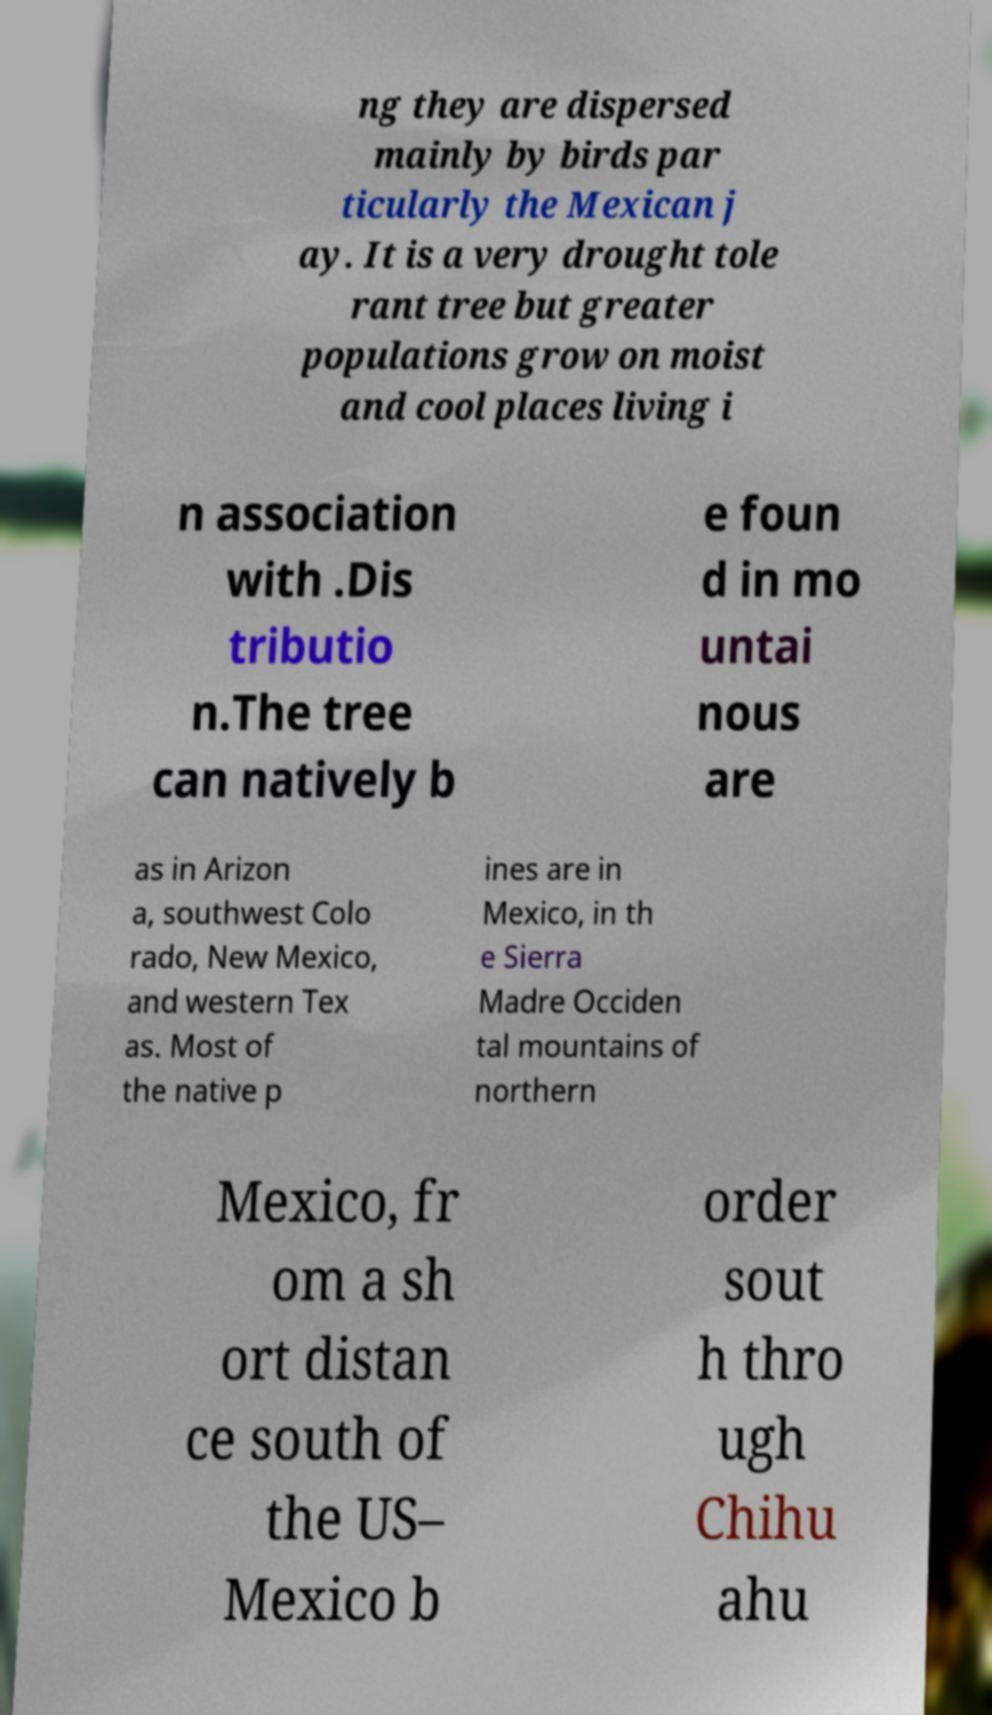Could you assist in decoding the text presented in this image and type it out clearly? ng they are dispersed mainly by birds par ticularly the Mexican j ay. It is a very drought tole rant tree but greater populations grow on moist and cool places living i n association with .Dis tributio n.The tree can natively b e foun d in mo untai nous are as in Arizon a, southwest Colo rado, New Mexico, and western Tex as. Most of the native p ines are in Mexico, in th e Sierra Madre Occiden tal mountains of northern Mexico, fr om a sh ort distan ce south of the US– Mexico b order sout h thro ugh Chihu ahu 